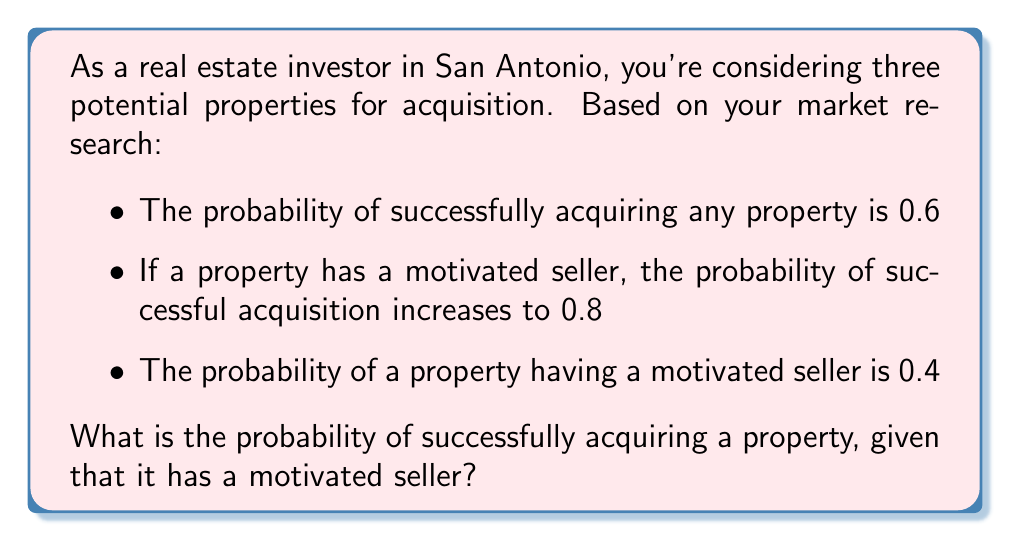Help me with this question. To solve this problem, we'll use Bayes' theorem, which is a form of conditional probability. Let's define our events:

A: Successfully acquiring a property
B: Property has a motivated seller

We're given:
$P(A) = 0.6$
$P(A|B) = 0.8$
$P(B) = 0.4$

We want to find $P(A|B)$, which is already given as 0.8. However, let's verify this using Bayes' theorem:

$$P(A|B) = \frac{P(B|A) \cdot P(A)}{P(B)}$$

We need to find $P(B|A)$, which we can calculate using the given information:

$$P(B|A) = \frac{P(A|B) \cdot P(B)}{P(A)}$$

$$P(B|A) = \frac{0.8 \cdot 0.4}{0.6} = \frac{0.32}{0.6} = \frac{8}{15} \approx 0.5333$$

Now we can verify $P(A|B)$:

$$P(A|B) = \frac{P(B|A) \cdot P(A)}{P(B)} = \frac{\frac{8}{15} \cdot 0.6}{0.4} = \frac{0.32}{0.4} = 0.8$$

This confirms the given probability and demonstrates how conditional probability works in this real estate scenario.
Answer: The probability of successfully acquiring a property, given that it has a motivated seller, is 0.8 or 80%. 